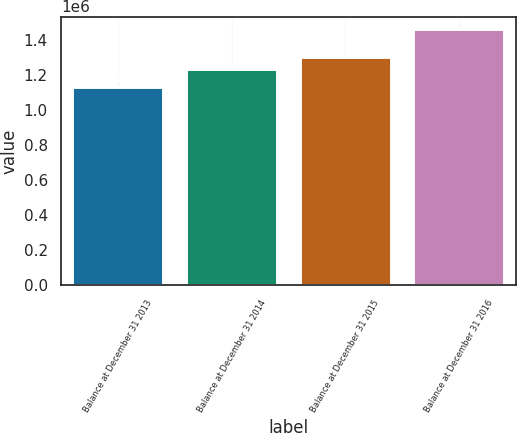Convert chart. <chart><loc_0><loc_0><loc_500><loc_500><bar_chart><fcel>Balance at December 31 2013<fcel>Balance at December 31 2014<fcel>Balance at December 31 2015<fcel>Balance at December 31 2016<nl><fcel>1.13078e+06<fcel>1.2353e+06<fcel>1.3027e+06<fcel>1.4626e+06<nl></chart> 